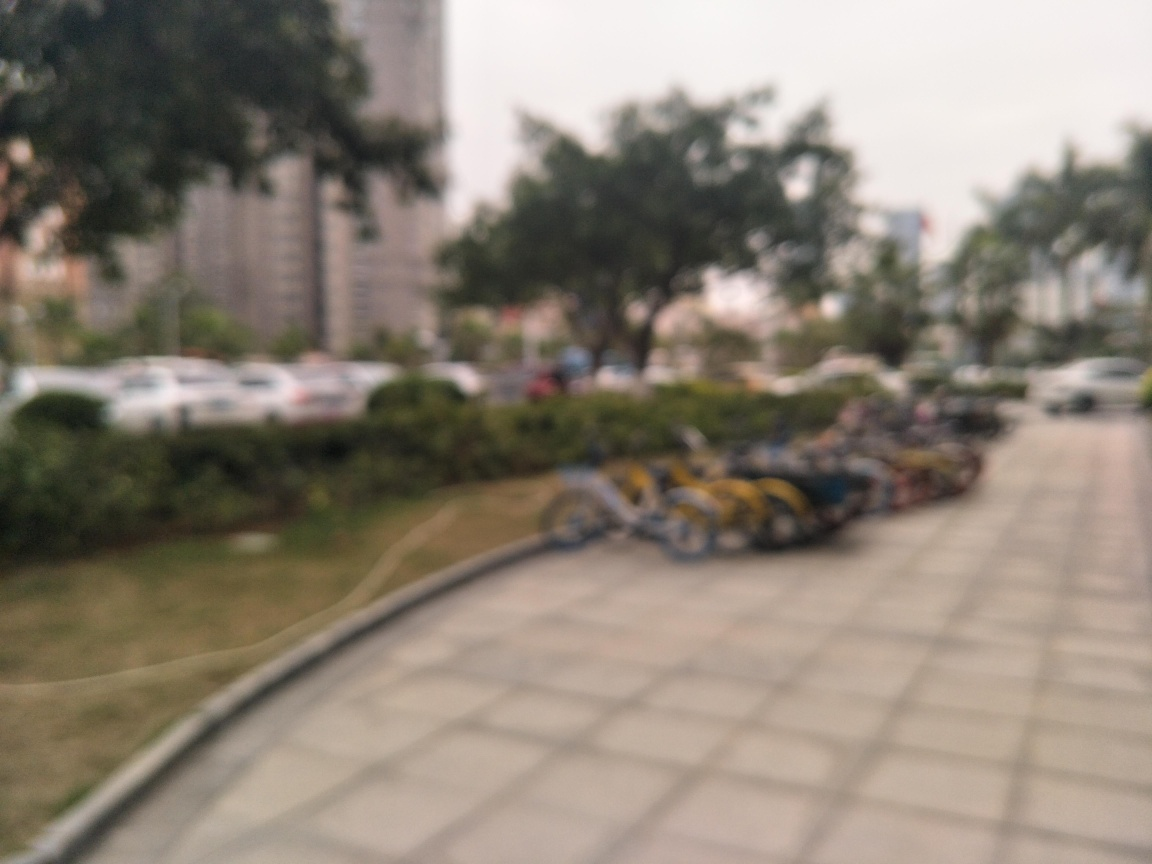What is the clarity of this image?
A. poor
B. good
C. average The clarity of the image is indeed poor, as it is blurry and lacks sharpness, making it difficult to discern fine details. This could be due to a focus issue or camera movement during the shot. 